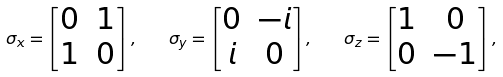Convert formula to latex. <formula><loc_0><loc_0><loc_500><loc_500>\sigma _ { x } = \left [ \begin{matrix} 0 & 1 \\ 1 & 0 \end{matrix} \right ] , \quad \sigma _ { y } = \left [ \begin{matrix} 0 & - i \\ i & 0 \end{matrix} \right ] , \quad \sigma _ { z } = \left [ \begin{matrix} 1 & 0 \\ 0 & - 1 \end{matrix} \right ] ,</formula> 